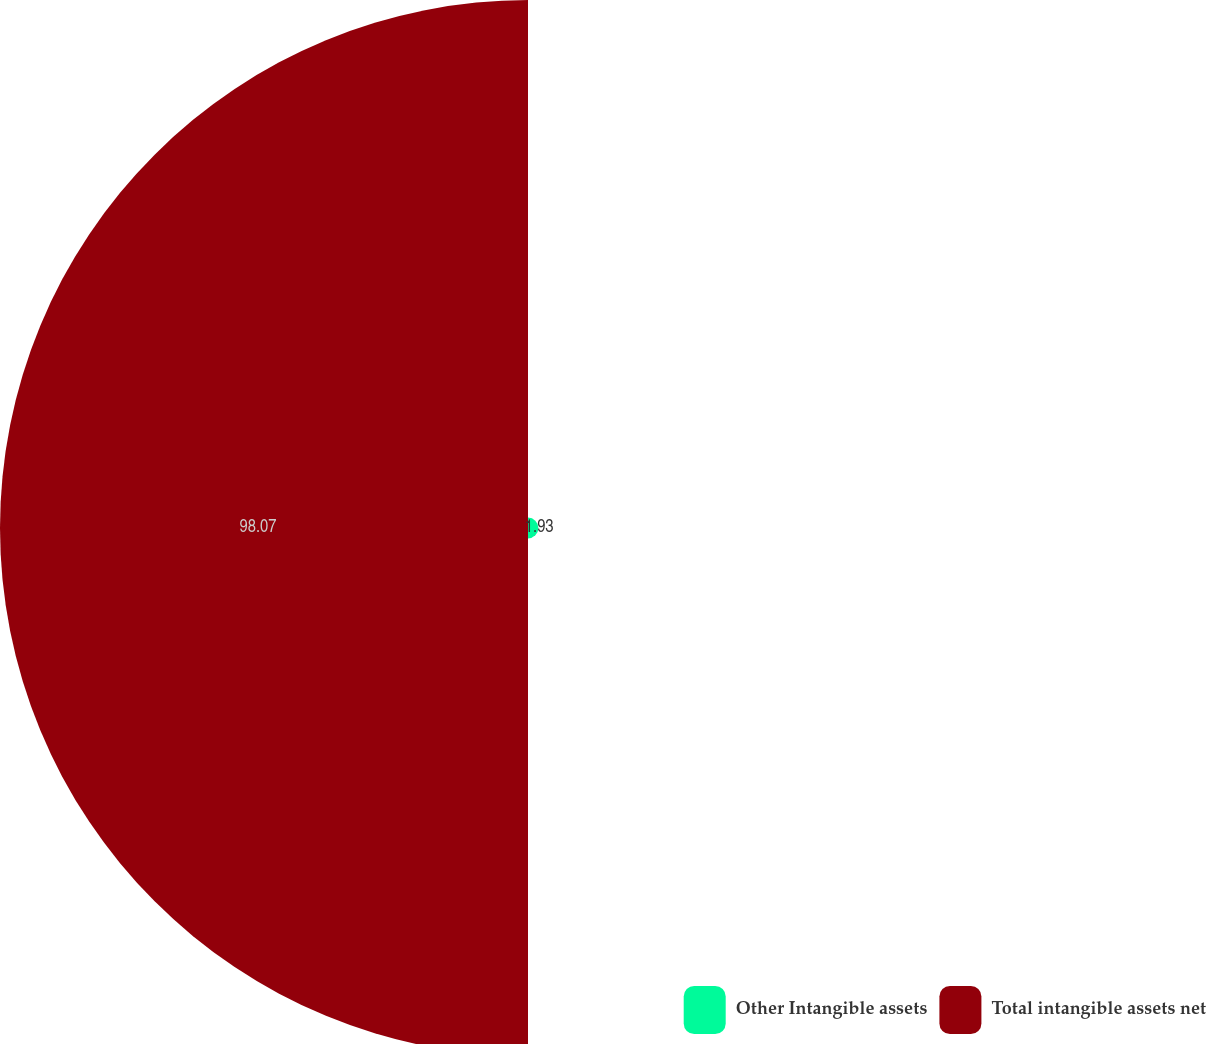Convert chart to OTSL. <chart><loc_0><loc_0><loc_500><loc_500><pie_chart><fcel>Other Intangible assets<fcel>Total intangible assets net<nl><fcel>1.93%<fcel>98.07%<nl></chart> 